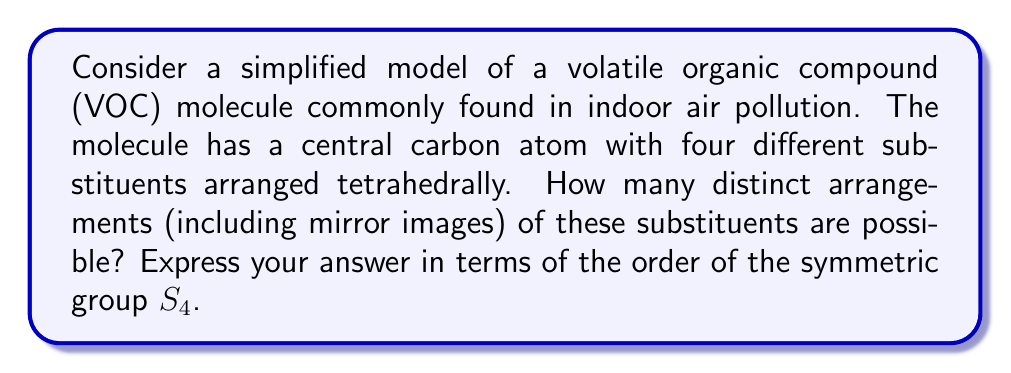Can you solve this math problem? To solve this problem, we need to consider the symmetries of a tetrahedral structure and relate it to permutation groups.

1) In a tetrahedral structure, we have 4 substituents arranged around a central atom. This corresponds to the symmetric group $S_4$, which contains all permutations of 4 elements.

2) The order of $S_4$ is $4! = 24$. This represents all possible ways to arrange 4 distinct objects.

3) However, in molecular structures, we need to consider rotational symmetries. A tetrahedral molecule has 12 rotational symmetries:
   - The identity operation (1)
   - Rotations by 120° around 4 axes through each vertex to the opposite face (8)
   - Rotations by 180° around 3 axes through the midpoints of opposite edges (3)

4) These rotational symmetries form a subgroup of $S_4$ known as the tetrahedral group, $T_d$, which has order 12.

5) The number of distinct arrangements, including mirror images, is given by the index of $T_d$ in $S_4$:

   $$[S_4 : T_d] = \frac{|S_4|}{|T_d|} = \frac{24}{12} = 2$$

6) Therefore, there are 2 distinct arrangements, which correspond to the two enantiomers (mirror images) of the molecule.

In terms of the order of $S_4$, we can express this as:

$$\text{Number of distinct arrangements} = \frac{|S_4|}{12} = \frac{|S_4|}{2}$$
Answer: $\frac{|S_4|}{2}$ or $\frac{|S_4|}{12}$ 